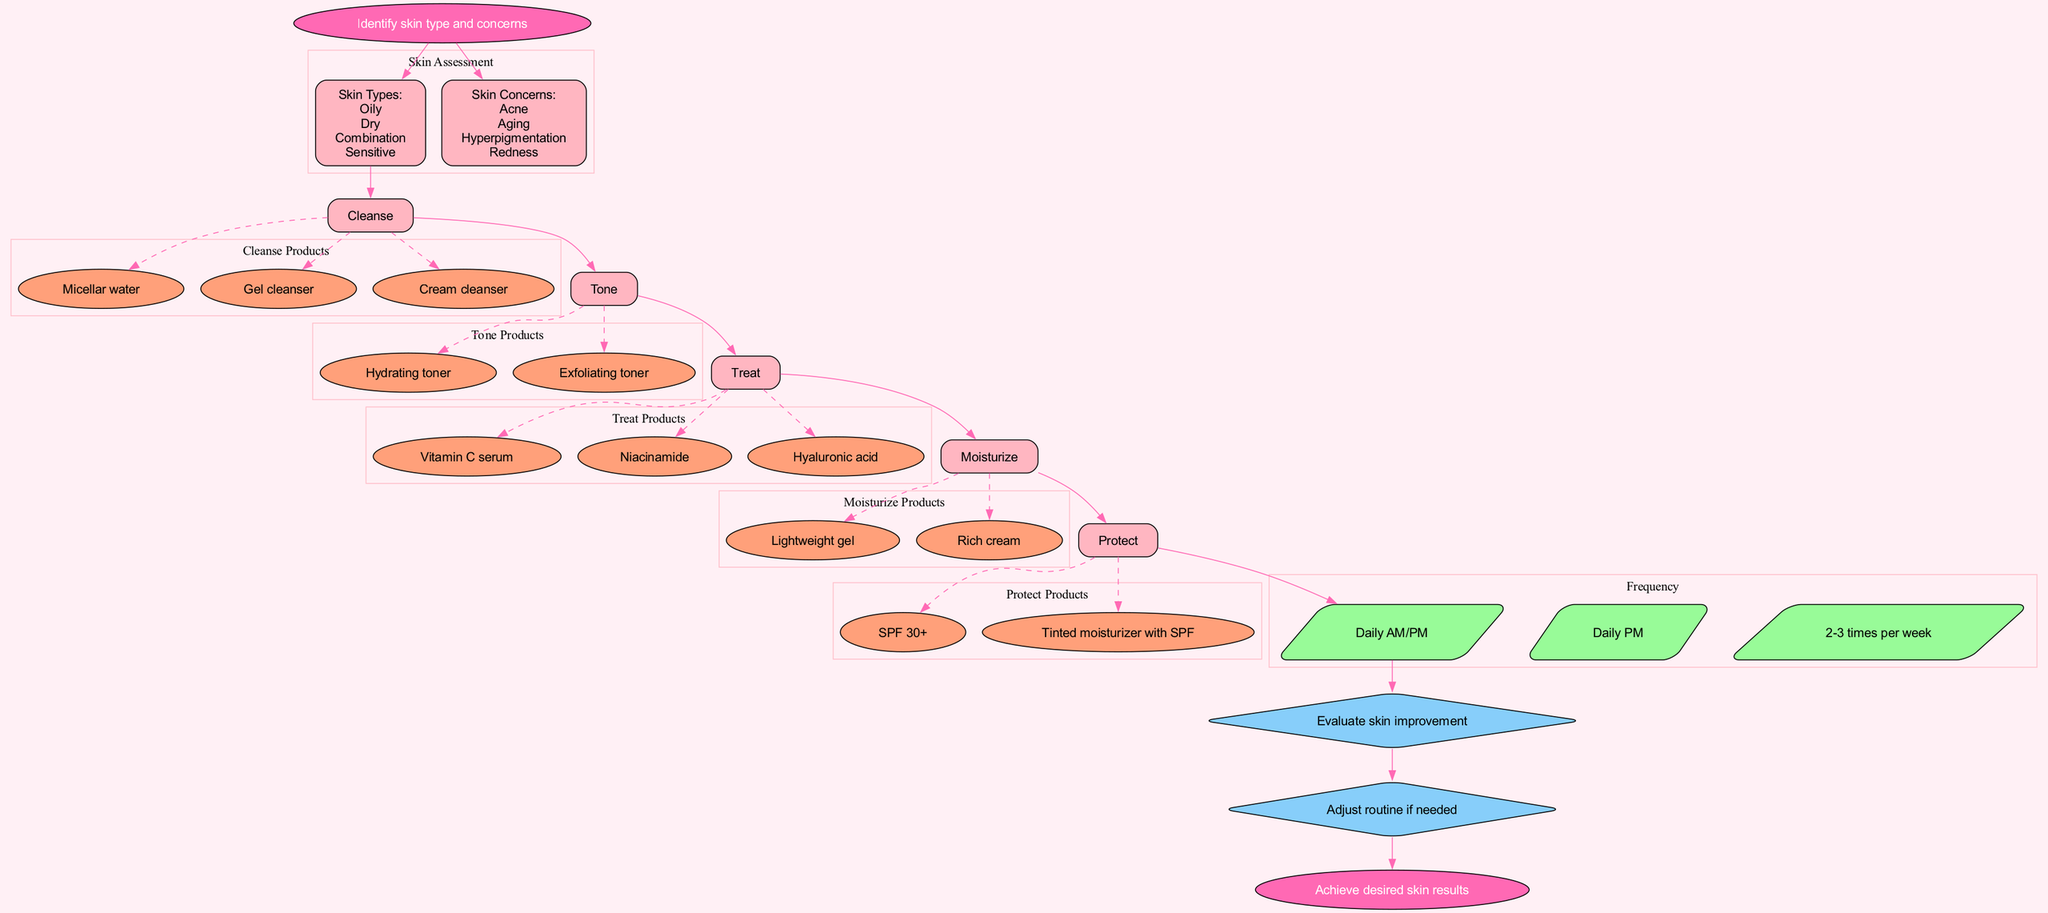What is the starting point of the clinical pathway? The starting point is labeled as "Identify skin type and concerns," which indicates where the process begins.
Answer: Identify skin type and concerns How many skin types are mentioned in the diagram? The diagram lists four skin types: Oily, Dry, Combination, and Sensitive, thus counting them gives a total of four.
Answer: 4 What are the steps involved in the skincare routine? The skincare routine consists of five steps: Cleanse, Tone, Treat, Moisturize, and Protect, which can be identified as labels in the pathway.
Answer: Cleanse, Tone, Treat, Moisturize, Protect Which product is associated with the "Tone" step? For the "Tone" step, the diagram includes two products: Hydrating toner and Exfoliating toner, indicating the options available for this routine step.
Answer: Hydrating toner, Exfoliating toner What frequency option is linked to the "Protect" step? The "Protect" step is connected to the frequency option labeled "Daily AM/PM," specifying how often to apply this particular step in the routine.
Answer: Daily AM/PM How many assessment points are included in the pathway? The pathway has two assessment points: Evaluate skin improvement and Adjust routine if needed, so when counting these points, the total is two.
Answer: 2 What do you need to do if you assess and find your skin needs an adjustment? If at the assessment points you evaluate and find skin improvement is lacking, the diagram suggests you would "Adjust routine if needed," which indicates a necessary action after evaluation.
Answer: Adjust routine if needed Identify a product recommended for the "Treat" step. The "Treat" step includes various products, such as Vitamin C serum, Niacinamide, and Hyaluronic acid, providing multiple options for treating specific skin concerns.
Answer: Vitamin C serum, Niacinamide, Hyaluronic acid What is the end result of following this clinical pathway? The endpoint of the clinical pathway says, "Achieve desired skin results," summarizing the ultimate goal of the skincare routine.
Answer: Achieve desired skin results 